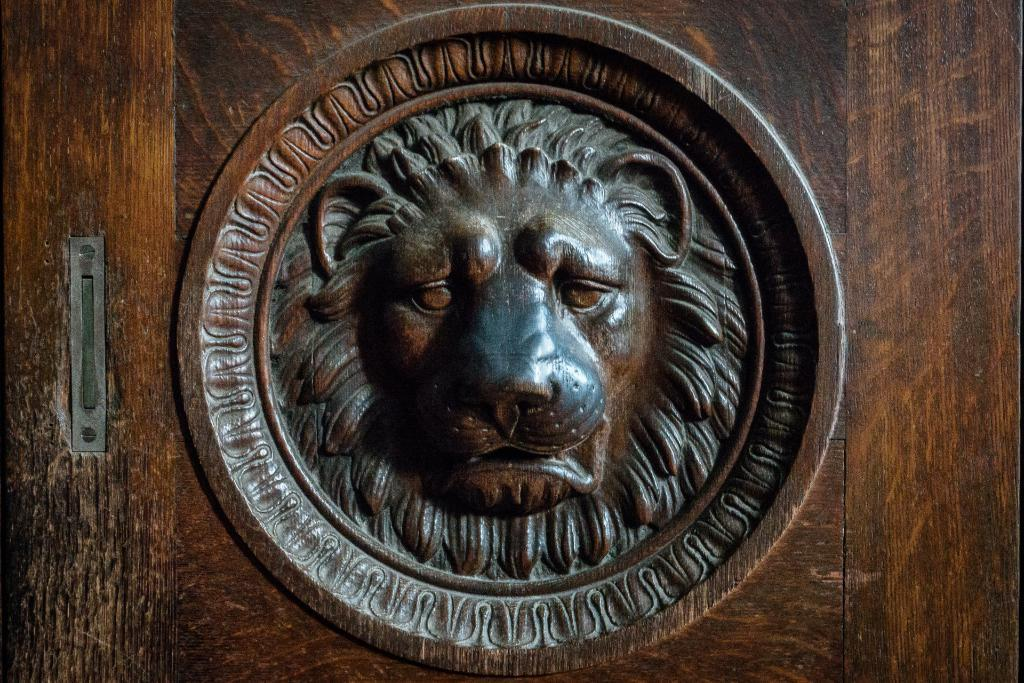What type of door is featured in the image? There is a wooden door in the picture. Can you describe any unique features of the wooden door? The wooden door has an architectural design of a lion face. What type of clam is visible on the door in the image? There is no clam present on the door in the image; it features a lion face design. What time of day is depicted in the image? The time of day is not mentioned or depicted in the image. 